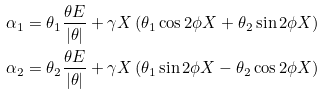<formula> <loc_0><loc_0><loc_500><loc_500>\alpha _ { 1 } & = \theta _ { 1 } \frac { \theta E } { | \theta | } + \gamma X \left ( \theta _ { 1 } \cos { 2 \phi X } + \theta _ { 2 } \sin { 2 \phi X } \right ) \\ \alpha _ { 2 } & = \theta _ { 2 } \frac { \theta E } { | \theta | } + \gamma X \left ( \theta _ { 1 } \sin { 2 \phi X } - \theta _ { 2 } \cos { 2 \phi X } \right )</formula> 